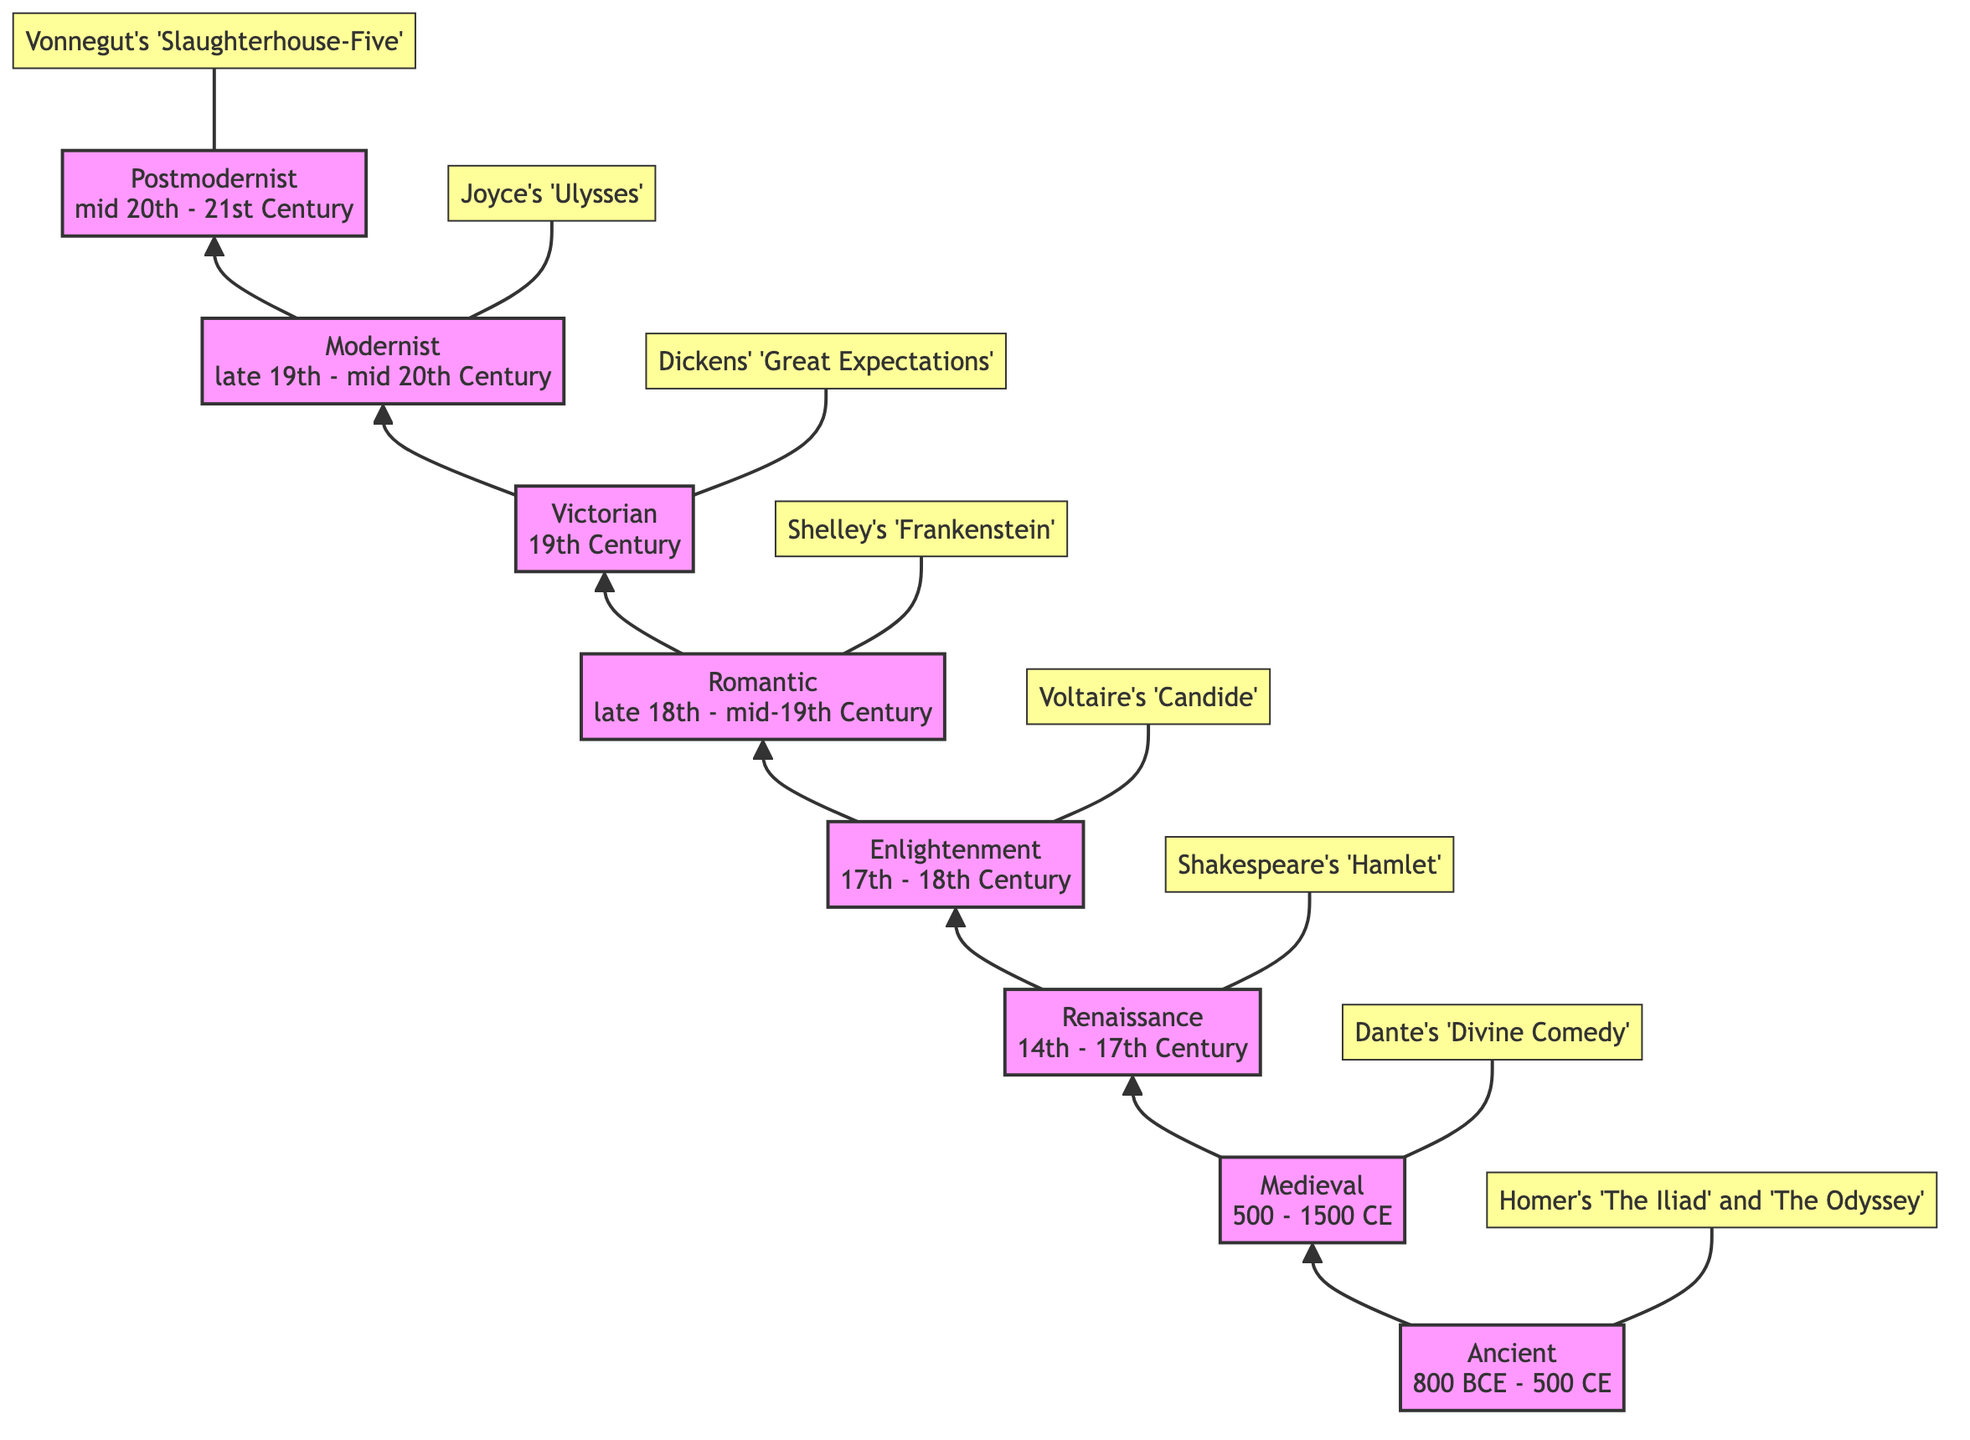What is the topmost literary period in the diagram? The diagram clearly indicates the highest node, which is labeled "Postmodernist" and represents the topmost literary period of progression.
Answer: Postmodernist Which period does "Great Expectations" belong to? Following the arrow flow upward, "Great Expectations" is linked directly to the "Victorian" period, indicating that it belongs to that literary era.
Answer: Victorian How many literary periods are depicted in the diagram? By counting the nodes in the diagram, there are a total of eight periods represented, each connected sequentially from bottom to top.
Answer: 8 What is the time frame for the Renaissance period? The Renaissance period is depicted in the diagram with the time frame "14th - 17th Century" right next to the period label itself, providing clear information.
Answer: 14th - 17th Century Which work is associated with the Medieval period? In the diagram, the Medieval period is connected to "Dante's 'Divine Comedy'", clearly indicating this literary work as its highlight.
Answer: Dante's 'Divine Comedy' What is the relationship between the Romantic and Victorian periods? The diagram shows a direct upward flow from the Romantic period to the Victorian period, depicting that the Victorian period follows the Romantic period in the literary timeline.
Answer: Sequential relationship Which author is highlighted in the Enlightenment period? Looking at the highlights for the Enlightenment period, "Voltaire's 'Candide'" is specifically mentioned, indicating Voltaire as the associated author for this era.
Answer: Voltaire Which literary era corresponds to the time frame "mid 20th - 21st Century"? The node label in the diagram corresponding to the time frame "mid 20th - 21st Century" is marked as the "Postmodernist" era, confirming this association.
Answer: Postmodernist 